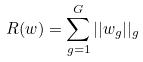<formula> <loc_0><loc_0><loc_500><loc_500>R ( w ) = \sum _ { g = 1 } ^ { G } | | w _ { g } | | _ { g }</formula> 